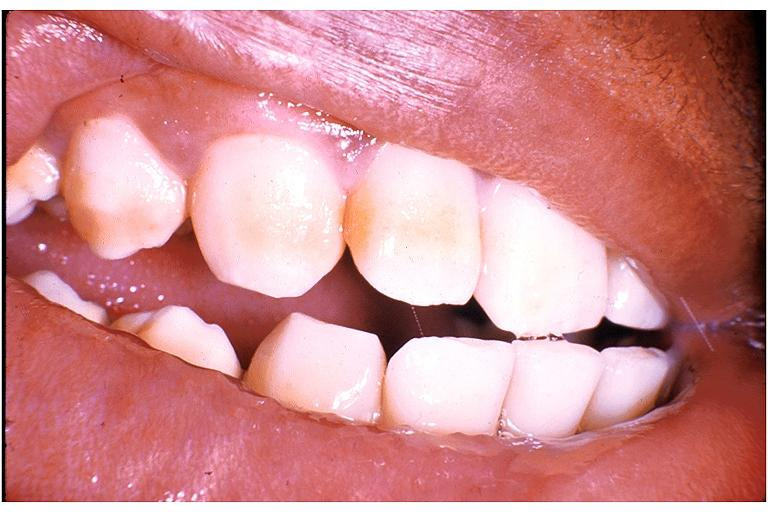what is present?
Answer the question using a single word or phrase. Oral 